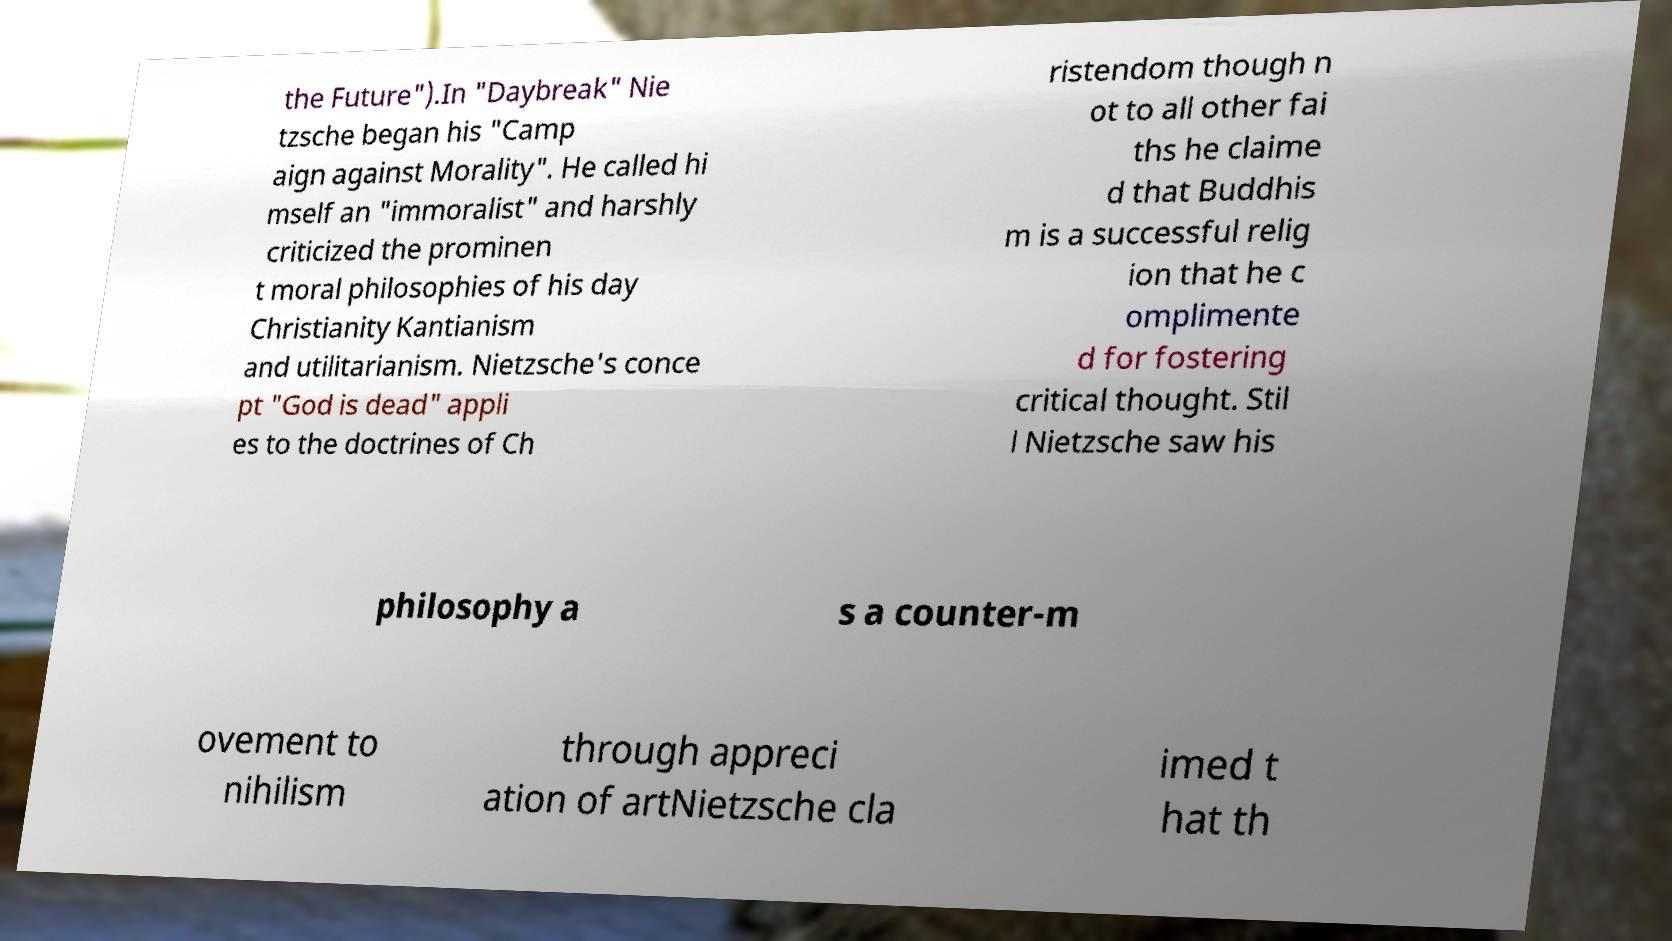Can you read and provide the text displayed in the image?This photo seems to have some interesting text. Can you extract and type it out for me? the Future").In "Daybreak" Nie tzsche began his "Camp aign against Morality". He called hi mself an "immoralist" and harshly criticized the prominen t moral philosophies of his day Christianity Kantianism and utilitarianism. Nietzsche's conce pt "God is dead" appli es to the doctrines of Ch ristendom though n ot to all other fai ths he claime d that Buddhis m is a successful relig ion that he c omplimente d for fostering critical thought. Stil l Nietzsche saw his philosophy a s a counter-m ovement to nihilism through appreci ation of artNietzsche cla imed t hat th 